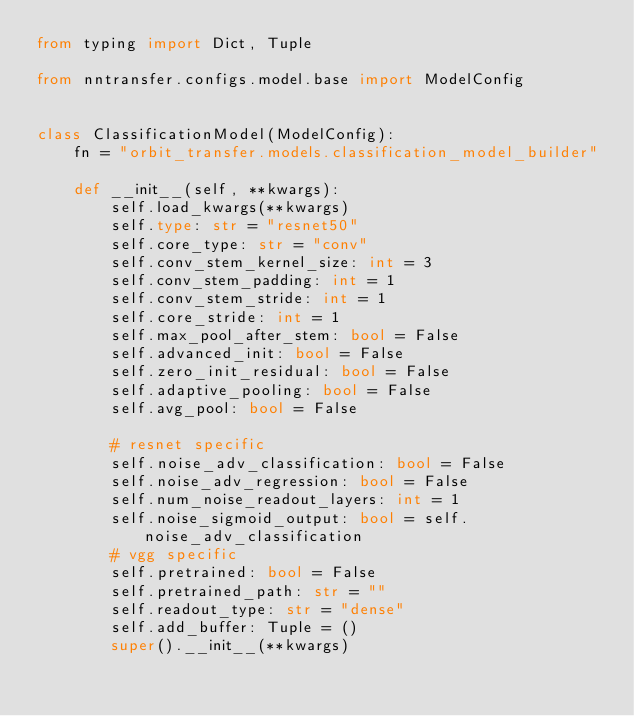<code> <loc_0><loc_0><loc_500><loc_500><_Python_>from typing import Dict, Tuple

from nntransfer.configs.model.base import ModelConfig


class ClassificationModel(ModelConfig):
    fn = "orbit_transfer.models.classification_model_builder"

    def __init__(self, **kwargs):
        self.load_kwargs(**kwargs)
        self.type: str = "resnet50"
        self.core_type: str = "conv"
        self.conv_stem_kernel_size: int = 3
        self.conv_stem_padding: int = 1
        self.conv_stem_stride: int = 1
        self.core_stride: int = 1
        self.max_pool_after_stem: bool = False
        self.advanced_init: bool = False
        self.zero_init_residual: bool = False
        self.adaptive_pooling: bool = False
        self.avg_pool: bool = False

        # resnet specific
        self.noise_adv_classification: bool = False
        self.noise_adv_regression: bool = False
        self.num_noise_readout_layers: int = 1
        self.noise_sigmoid_output: bool = self.noise_adv_classification
        # vgg specific
        self.pretrained: bool = False
        self.pretrained_path: str = ""
        self.readout_type: str = "dense"
        self.add_buffer: Tuple = ()
        super().__init__(**kwargs)
</code> 